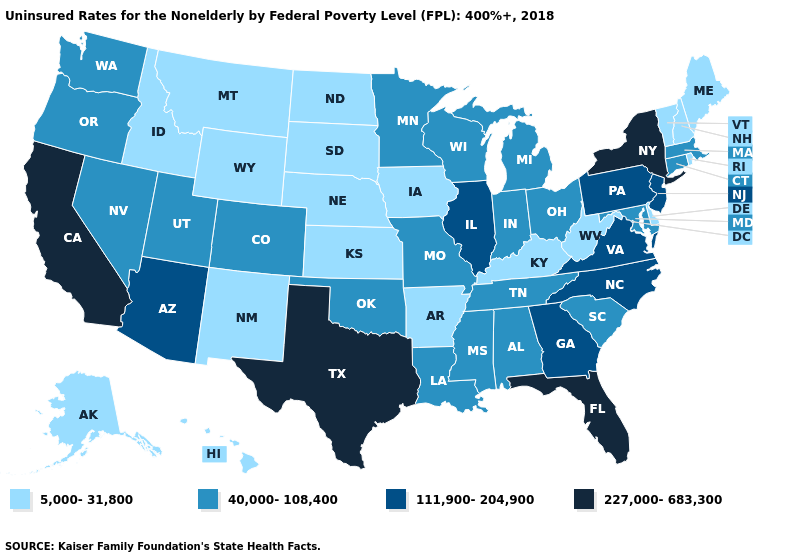What is the value of Oklahoma?
Be succinct. 40,000-108,400. Name the states that have a value in the range 227,000-683,300?
Concise answer only. California, Florida, New York, Texas. Which states have the lowest value in the West?
Answer briefly. Alaska, Hawaii, Idaho, Montana, New Mexico, Wyoming. How many symbols are there in the legend?
Short answer required. 4. Which states have the lowest value in the USA?
Keep it brief. Alaska, Arkansas, Delaware, Hawaii, Idaho, Iowa, Kansas, Kentucky, Maine, Montana, Nebraska, New Hampshire, New Mexico, North Dakota, Rhode Island, South Dakota, Vermont, West Virginia, Wyoming. Which states hav the highest value in the MidWest?
Write a very short answer. Illinois. Name the states that have a value in the range 111,900-204,900?
Keep it brief. Arizona, Georgia, Illinois, New Jersey, North Carolina, Pennsylvania, Virginia. Among the states that border Rhode Island , which have the highest value?
Keep it brief. Connecticut, Massachusetts. Does Wyoming have a higher value than Mississippi?
Be succinct. No. Among the states that border California , which have the lowest value?
Write a very short answer. Nevada, Oregon. Name the states that have a value in the range 227,000-683,300?
Keep it brief. California, Florida, New York, Texas. Name the states that have a value in the range 5,000-31,800?
Keep it brief. Alaska, Arkansas, Delaware, Hawaii, Idaho, Iowa, Kansas, Kentucky, Maine, Montana, Nebraska, New Hampshire, New Mexico, North Dakota, Rhode Island, South Dakota, Vermont, West Virginia, Wyoming. Does Rhode Island have the lowest value in the Northeast?
Give a very brief answer. Yes. Which states have the lowest value in the USA?
Concise answer only. Alaska, Arkansas, Delaware, Hawaii, Idaho, Iowa, Kansas, Kentucky, Maine, Montana, Nebraska, New Hampshire, New Mexico, North Dakota, Rhode Island, South Dakota, Vermont, West Virginia, Wyoming. What is the value of Hawaii?
Concise answer only. 5,000-31,800. 